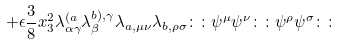<formula> <loc_0><loc_0><loc_500><loc_500>+ \epsilon \frac { 3 } { 8 } x _ { 3 } ^ { 2 } \lambda ^ { ( a } _ { \alpha \gamma } \lambda ^ { b ) , \gamma } _ { \beta } \lambda _ { a , \mu \nu } \lambda _ { b , \rho \sigma } \colon \colon \psi ^ { \mu } \psi ^ { \nu } \colon \colon \psi ^ { \rho } \psi ^ { \sigma } \colon \colon</formula> 